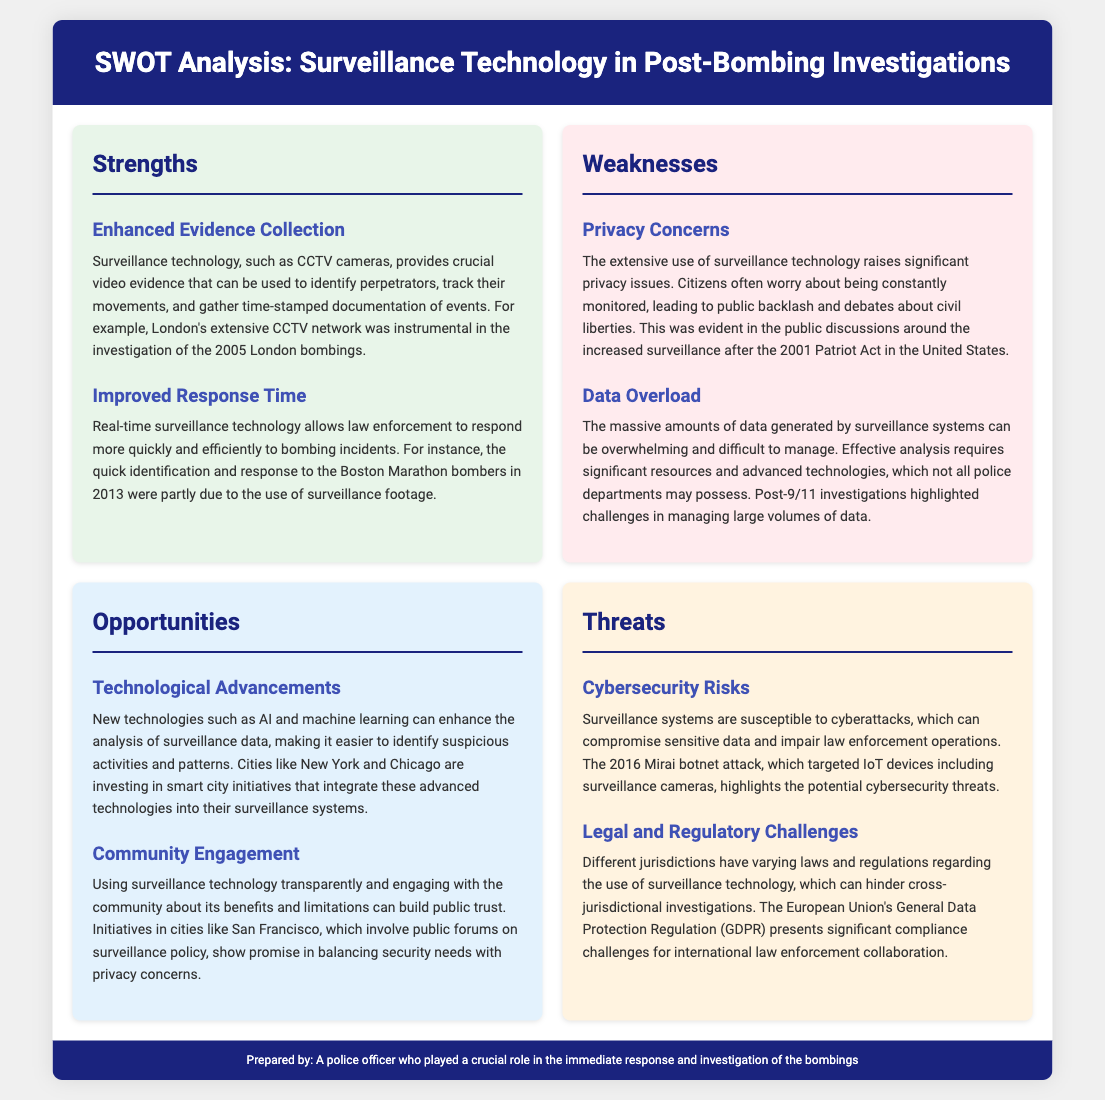What are the main strengths identified in the analysis? The strengths listed in the document include Enhanced Evidence Collection and Improved Response Time.
Answer: Enhanced Evidence Collection, Improved Response Time What example is given for Improved Response Time? The document mentions the quick identification and response to the Boston Marathon bombers in 2013 as an example.
Answer: Boston Marathon bombers in 2013 What is a significant threat related to surveillance technology mentioned in the analysis? The SWOT analysis points out Cybersecurity Risks as a notable threat.
Answer: Cybersecurity Risks Which technology is highlighted as an opportunity for enhancing surveillance analysis? The document refers to AI and machine learning as technologies that could enhance surveillance data analysis.
Answer: AI and machine learning How do Privacy Concerns impact the use of surveillance technology? According to the document, Privacy Concerns can lead to public backlash and debates about civil liberties.
Answer: Public backlash and debates about civil liberties What regulatory challenge regarding surveillance technology is noted in the analysis? The document states that Legal and Regulatory Challenges can hinder cross-jurisdictional investigations.
Answer: Legal and Regulatory Challenges What city is mentioned as engaging the community about surveillance policy? San Francisco is cited in the document for involving public forums on surveillance policy.
Answer: San Francisco What does data overload require to manage effectively? The document mentions that effective analysis requires significant resources and advanced technologies.
Answer: Significant resources and advanced technologies 